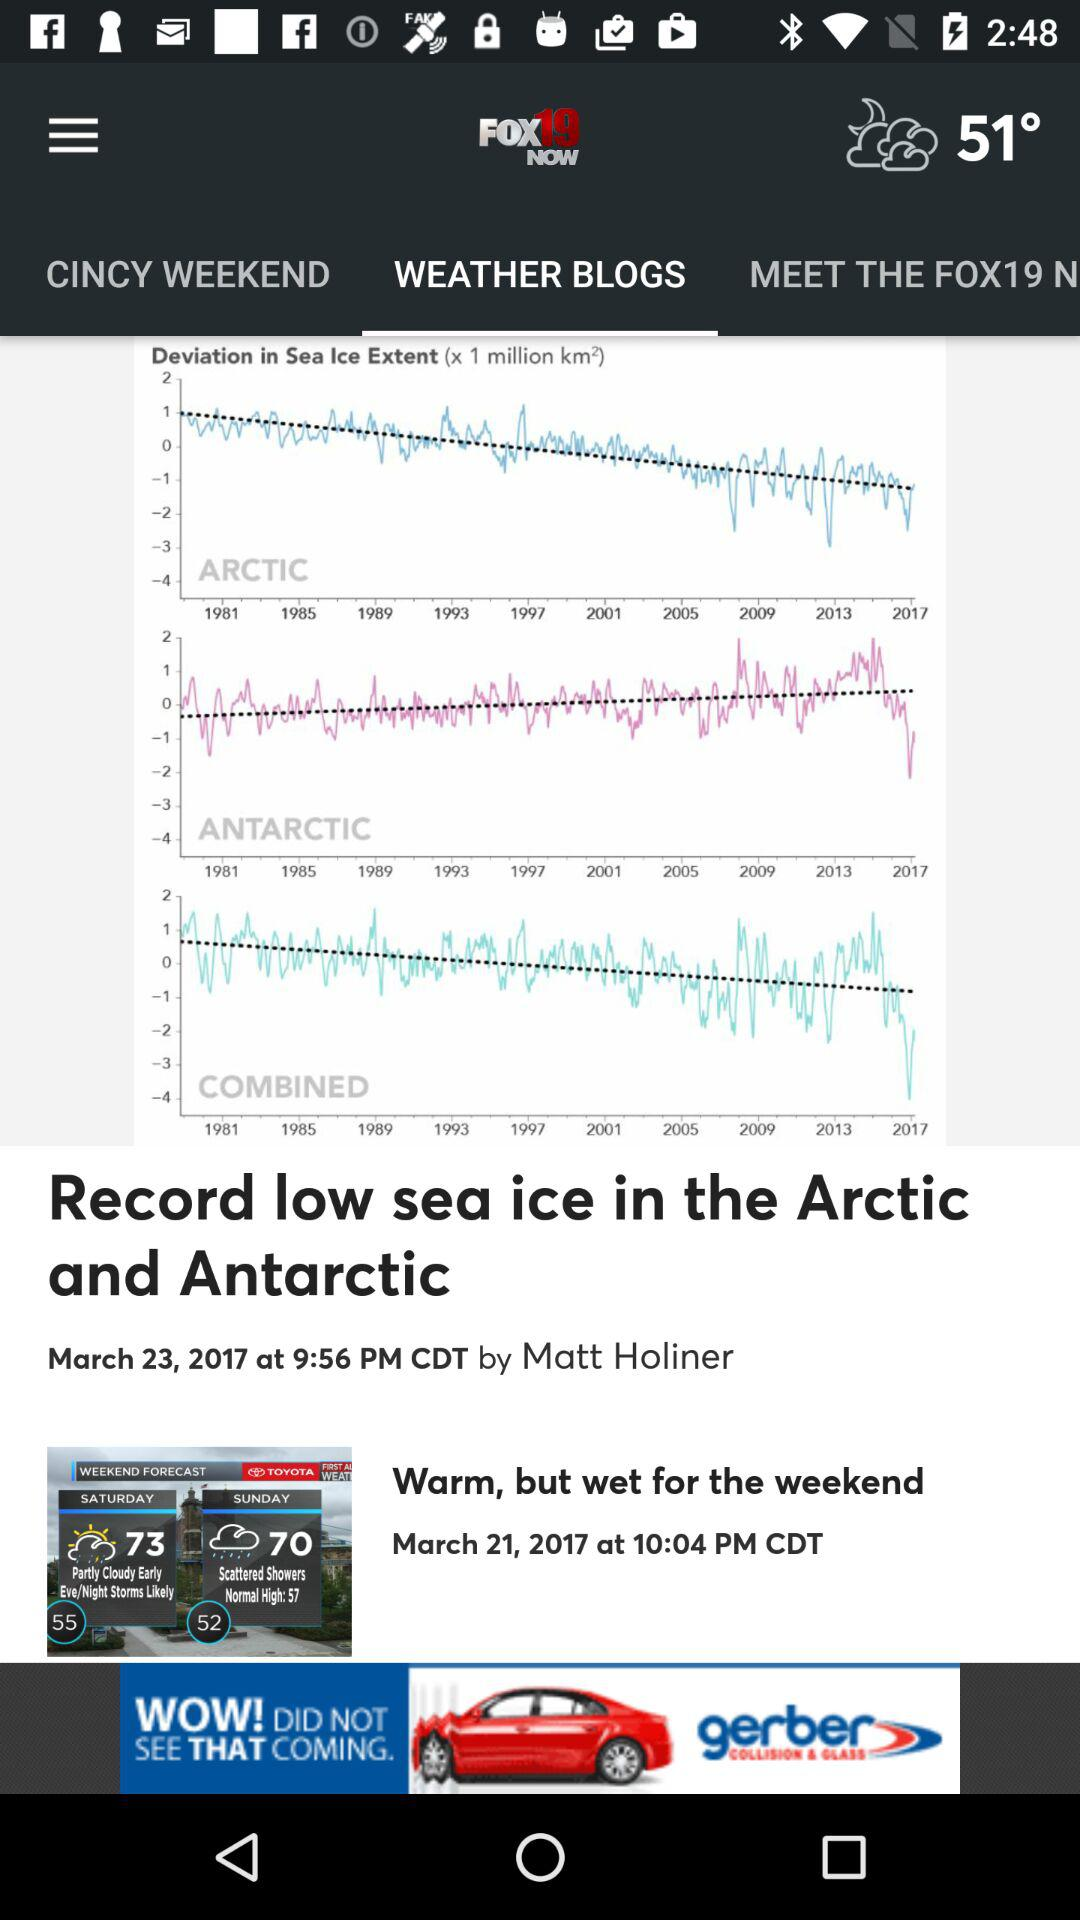What is the temperature? The temperature is 51°. 